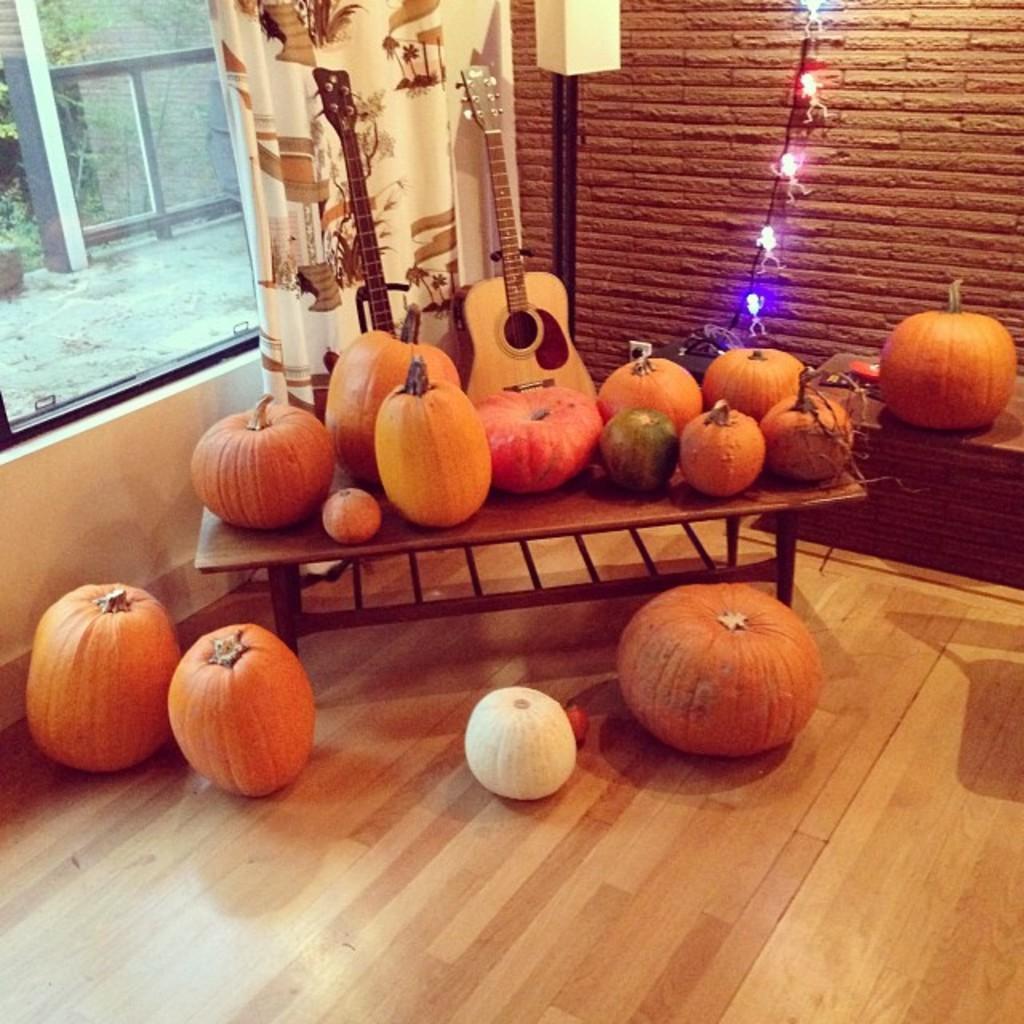Can you describe this image briefly? There is a floor which is in brown color and some plastic fruits are kept and there is a table of brown color and on that table there are plastic items are kept and a music instrument is placed at the wall and there is a glass window which is covered by a white curtain. 